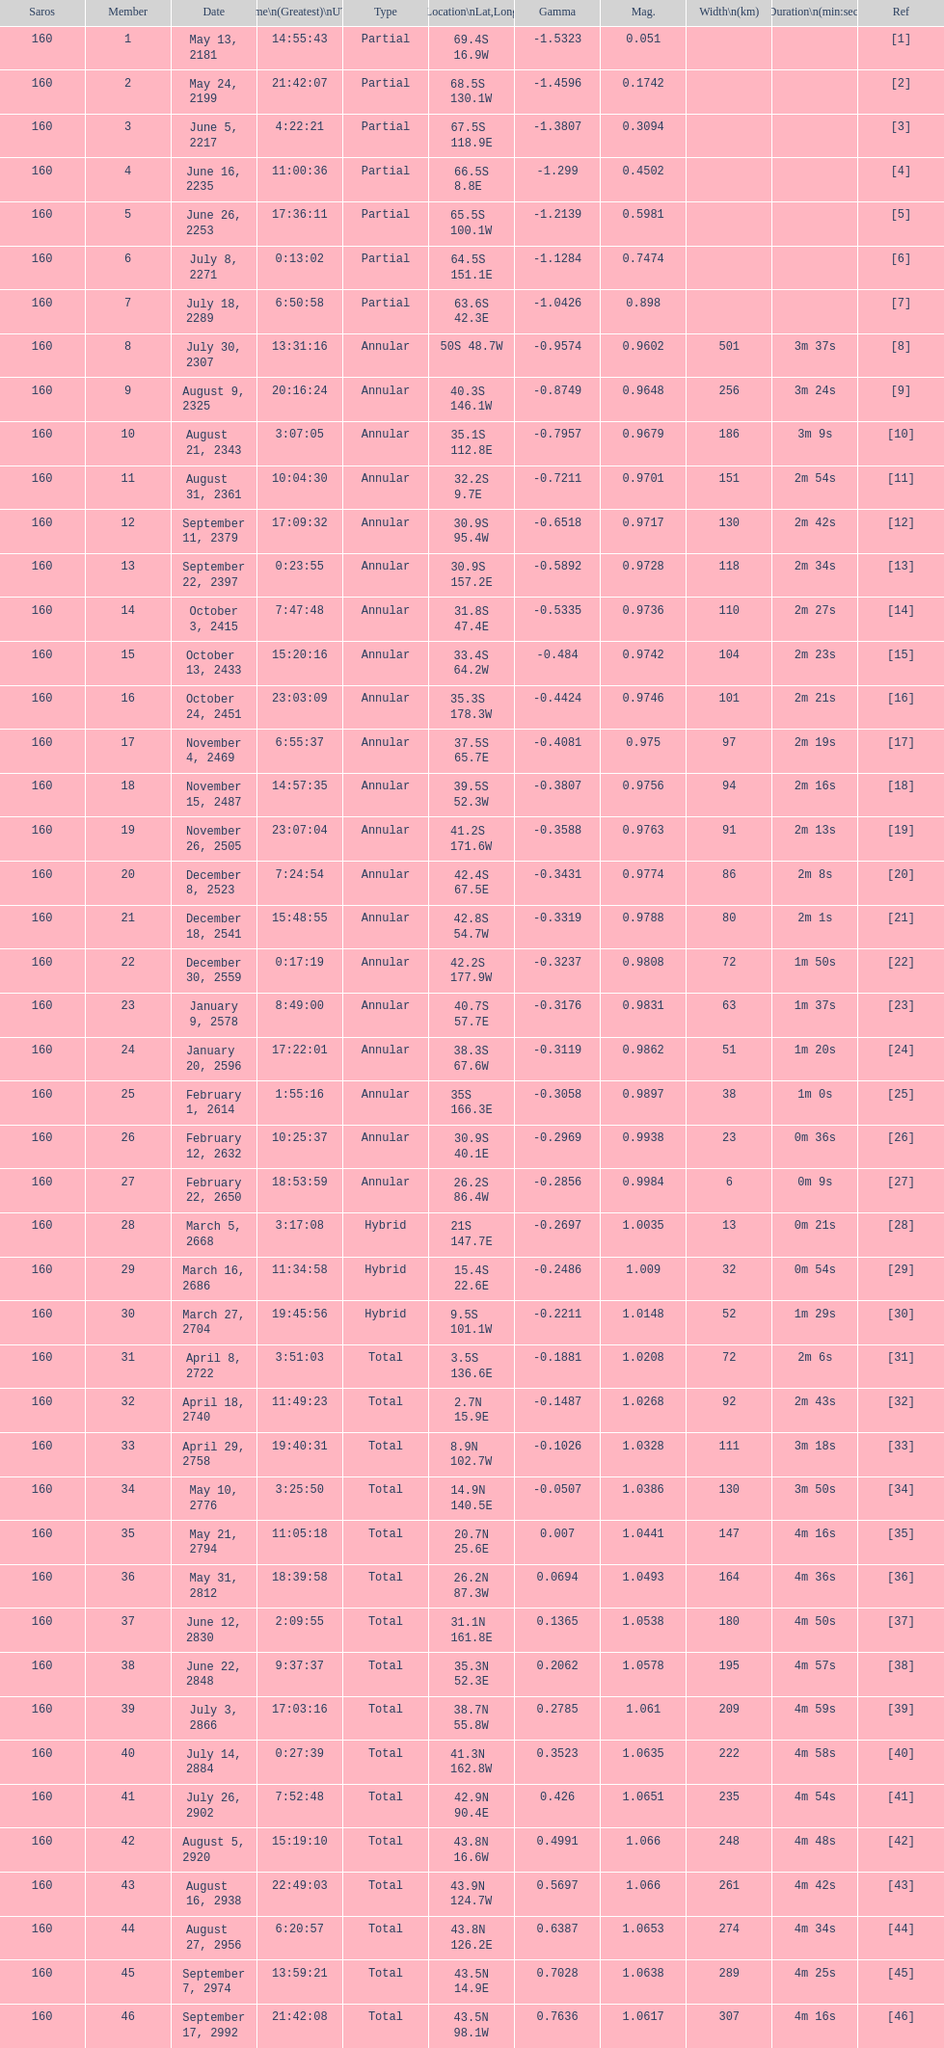Which one has a greater breadth, 8 or 21? 8. 